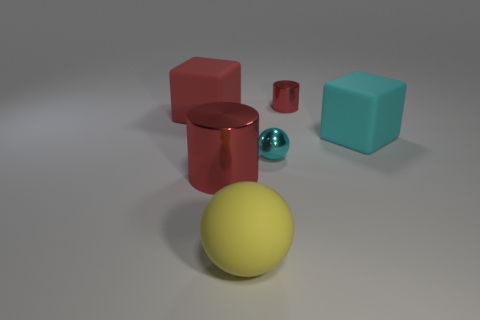There is another metal object that is the same color as the big metal object; what is its shape?
Your response must be concise. Cylinder. What material is the cyan cube?
Provide a short and direct response. Rubber. How many things are either red cylinders or large red cylinders?
Provide a succinct answer. 2. There is a metal thing left of the yellow rubber thing; does it have the same size as the red metal object to the right of the yellow ball?
Offer a very short reply. No. How many other objects are the same size as the red rubber object?
Offer a terse response. 3. What number of objects are large matte blocks to the right of the tiny cyan metallic thing or large things on the left side of the large red shiny cylinder?
Keep it short and to the point. 2. Is the tiny cyan object made of the same material as the big thing that is to the right of the yellow rubber sphere?
Make the answer very short. No. How many other things are there of the same shape as the big yellow thing?
Offer a very short reply. 1. What material is the large cyan thing on the right side of the tiny ball that is in front of the red shiny cylinder on the right side of the big rubber ball?
Keep it short and to the point. Rubber. Is the number of small cyan balls on the left side of the big yellow rubber object the same as the number of cyan matte cylinders?
Provide a succinct answer. Yes. 